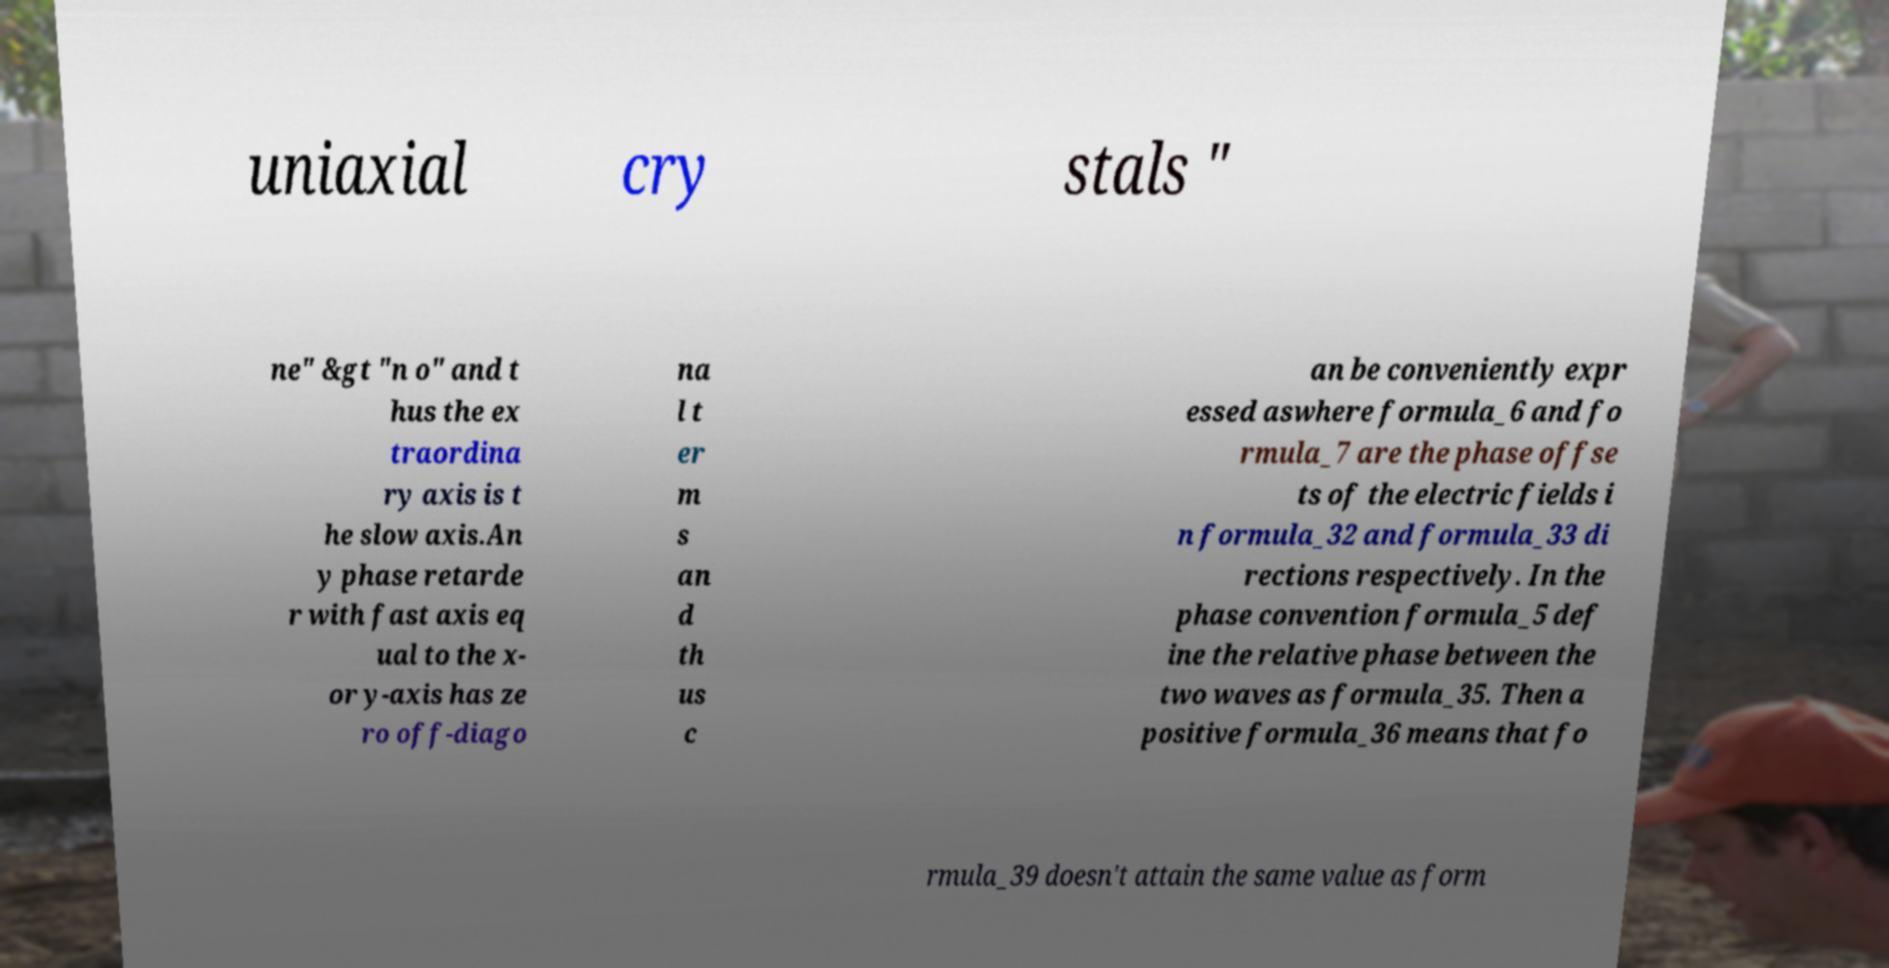Could you assist in decoding the text presented in this image and type it out clearly? uniaxial cry stals " ne" &gt "n o" and t hus the ex traordina ry axis is t he slow axis.An y phase retarde r with fast axis eq ual to the x- or y-axis has ze ro off-diago na l t er m s an d th us c an be conveniently expr essed aswhere formula_6 and fo rmula_7 are the phase offse ts of the electric fields i n formula_32 and formula_33 di rections respectively. In the phase convention formula_5 def ine the relative phase between the two waves as formula_35. Then a positive formula_36 means that fo rmula_39 doesn't attain the same value as form 